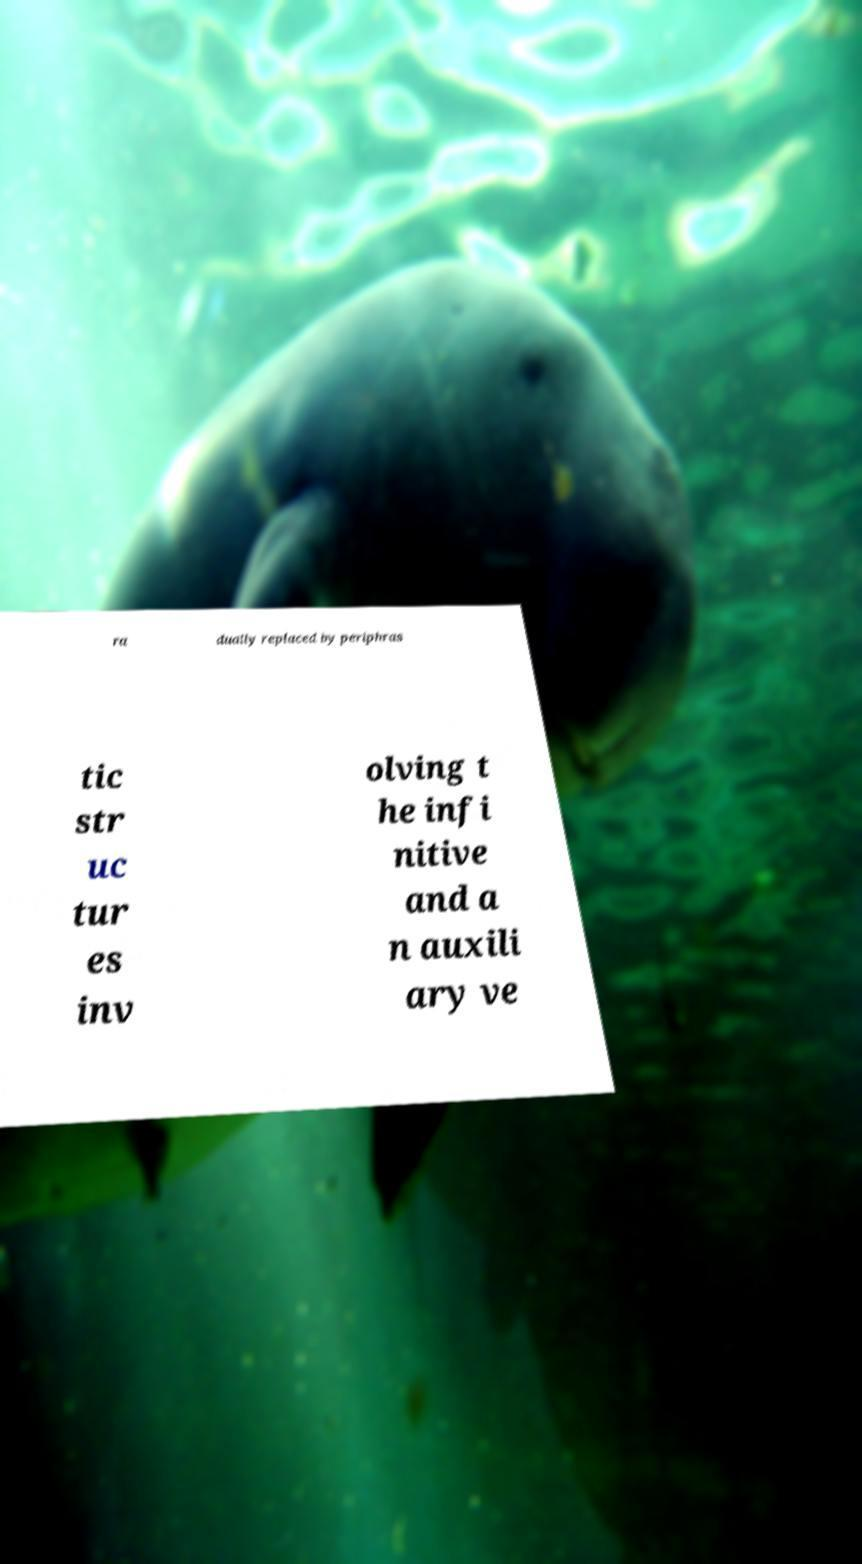Can you read and provide the text displayed in the image?This photo seems to have some interesting text. Can you extract and type it out for me? ra dually replaced by periphras tic str uc tur es inv olving t he infi nitive and a n auxili ary ve 